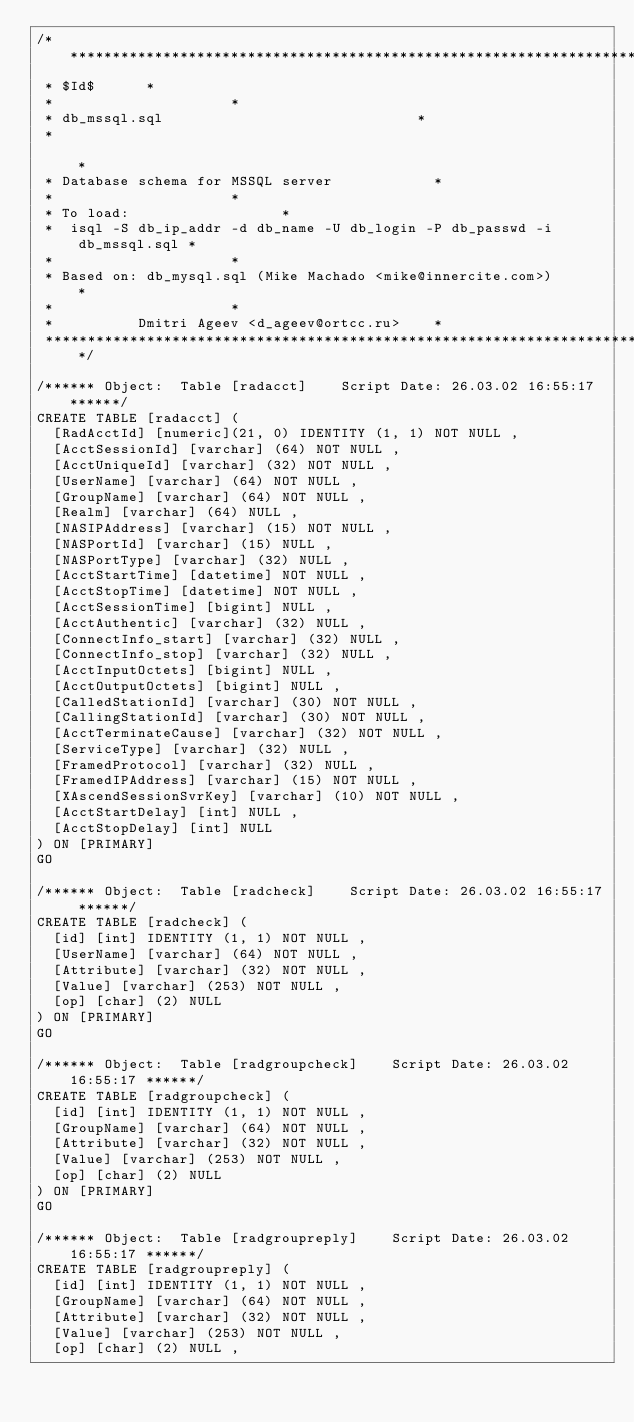<code> <loc_0><loc_0><loc_500><loc_500><_SQL_>/***************************************************************************
 * $Id$		   *
 *									   *
 * db_mssql.sql                 					   *
 *                                                                         *
 * Database schema for MSSQL server					   *
 *									   *
 * To load:								   *
 *  isql -S db_ip_addr -d db_name -U db_login -P db_passwd -i db_mssql.sql *
 *									   *
 * Based on: db_mysql.sql (Mike Machado <mike@innercite.com>)		   *
 *									   *
 *					Dmitri Ageev <d_ageev@ortcc.ru>    *
 ***************************************************************************/

/****** Object:  Table [radacct]    Script Date: 26.03.02 16:55:17 ******/
CREATE TABLE [radacct] (
	[RadAcctId] [numeric](21, 0) IDENTITY (1, 1) NOT NULL ,
	[AcctSessionId] [varchar] (64) NOT NULL ,
	[AcctUniqueId] [varchar] (32) NOT NULL ,
	[UserName] [varchar] (64) NOT NULL ,
	[GroupName] [varchar] (64) NOT NULL ,
	[Realm] [varchar] (64) NULL ,
	[NASIPAddress] [varchar] (15) NOT NULL ,
	[NASPortId] [varchar] (15) NULL ,
	[NASPortType] [varchar] (32) NULL ,
	[AcctStartTime] [datetime] NOT NULL ,
	[AcctStopTime] [datetime] NOT NULL ,
	[AcctSessionTime] [bigint] NULL ,
	[AcctAuthentic] [varchar] (32) NULL ,
	[ConnectInfo_start] [varchar] (32) NULL ,
	[ConnectInfo_stop] [varchar] (32) NULL ,
	[AcctInputOctets] [bigint] NULL ,
	[AcctOutputOctets] [bigint] NULL ,
	[CalledStationId] [varchar] (30) NOT NULL ,
	[CallingStationId] [varchar] (30) NOT NULL ,
	[AcctTerminateCause] [varchar] (32) NOT NULL ,
	[ServiceType] [varchar] (32) NULL ,
	[FramedProtocol] [varchar] (32) NULL ,
	[FramedIPAddress] [varchar] (15) NOT NULL ,
	[XAscendSessionSvrKey] [varchar] (10) NOT NULL ,
	[AcctStartDelay] [int] NULL ,
	[AcctStopDelay] [int] NULL
) ON [PRIMARY]
GO

/****** Object:  Table [radcheck]    Script Date: 26.03.02 16:55:17 ******/
CREATE TABLE [radcheck] (
	[id] [int] IDENTITY (1, 1) NOT NULL ,
	[UserName] [varchar] (64) NOT NULL ,
	[Attribute] [varchar] (32) NOT NULL ,
	[Value] [varchar] (253) NOT NULL ,
	[op] [char] (2) NULL
) ON [PRIMARY]
GO

/****** Object:  Table [radgroupcheck]    Script Date: 26.03.02 16:55:17 ******/
CREATE TABLE [radgroupcheck] (
	[id] [int] IDENTITY (1, 1) NOT NULL ,
	[GroupName] [varchar] (64) NOT NULL ,
	[Attribute] [varchar] (32) NOT NULL ,
	[Value] [varchar] (253) NOT NULL ,
	[op] [char] (2) NULL
) ON [PRIMARY]
GO

/****** Object:  Table [radgroupreply]    Script Date: 26.03.02 16:55:17 ******/
CREATE TABLE [radgroupreply] (
	[id] [int] IDENTITY (1, 1) NOT NULL ,
	[GroupName] [varchar] (64) NOT NULL ,
	[Attribute] [varchar] (32) NOT NULL ,
	[Value] [varchar] (253) NOT NULL ,
	[op] [char] (2) NULL ,</code> 